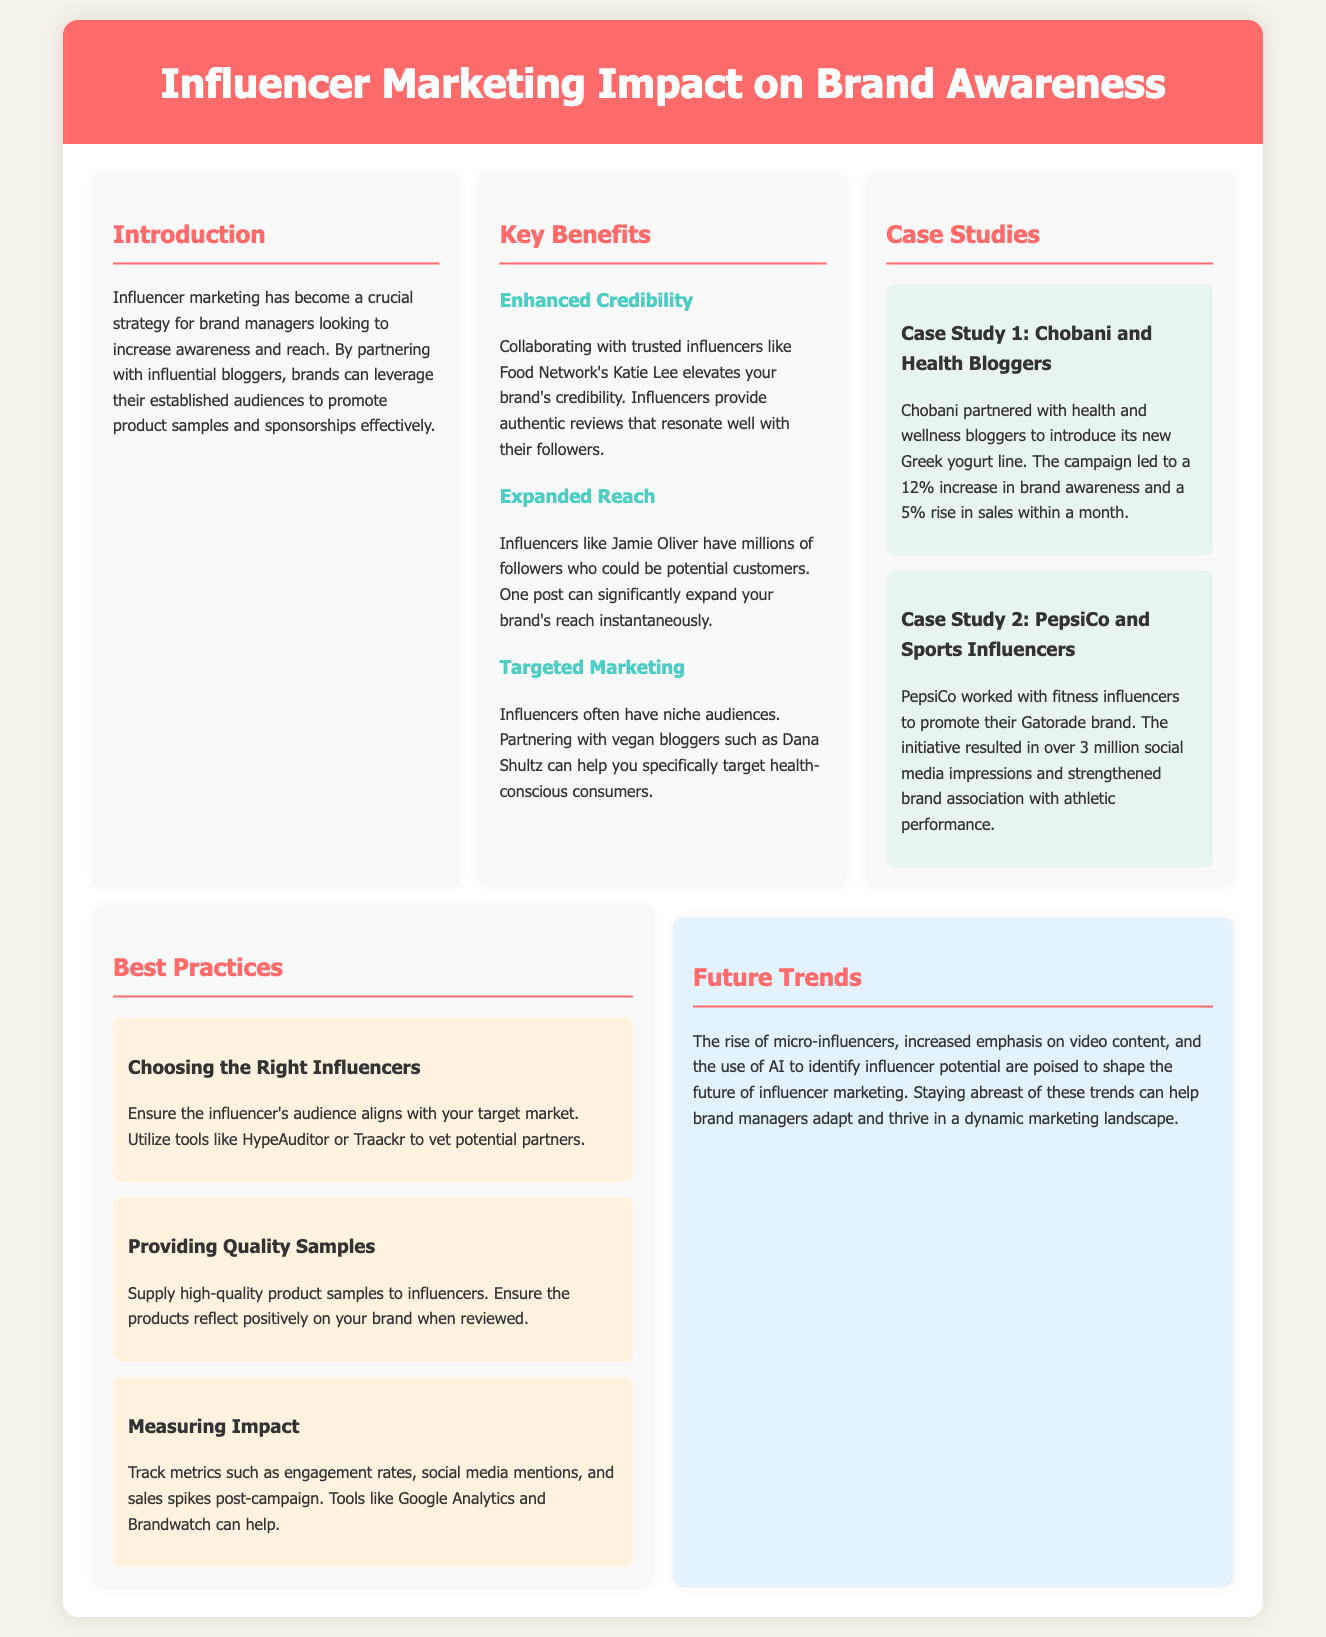What is the primary strategy discussed for brand managers? The introduction specifies that the primary strategy discussed is influencer marketing to increase awareness and reach.
Answer: Influencer marketing Who is the influencer mentioned that enhances brand credibility? The document states that collaborating with trusted influencers like Food Network's Katie Lee enhances brand credibility.
Answer: Katie Lee What was the percentage increase in brand awareness for Chobani's campaign? The case study for Chobani mentions a 12% increase in brand awareness from its campaign.
Answer: 12% Which type of influencers did PepsiCo collaborate with for their Gatorade brand? The document specifies that PepsiCo worked with fitness influencers to promote their Gatorade brand.
Answer: Fitness influencers What should brand managers use to vet potential influencer partners? The best practices section suggests utilizing tools like HypeAuditor or Traackr for vetting.
Answer: HypeAuditor or Traackr What are two key metrics suggested to measure the impact of influencer marketing? The document suggests tracking engagement rates and social media mentions as key metrics.
Answer: Engagement rates, social media mentions What future trend is highlighted regarding the type of influencers? The future trends section mentions the rise of micro-influencers as a notable trend.
Answer: Micro-influencers What is one recommendation for product samples in best practices? The best practices section emphasizes supplying high-quality product samples to influencers.
Answer: High-quality product samples Which platform can help track sales spikes post-campaign? The best practices suggest using tools like Google Analytics to track sales spikes after campaigns.
Answer: Google Analytics 